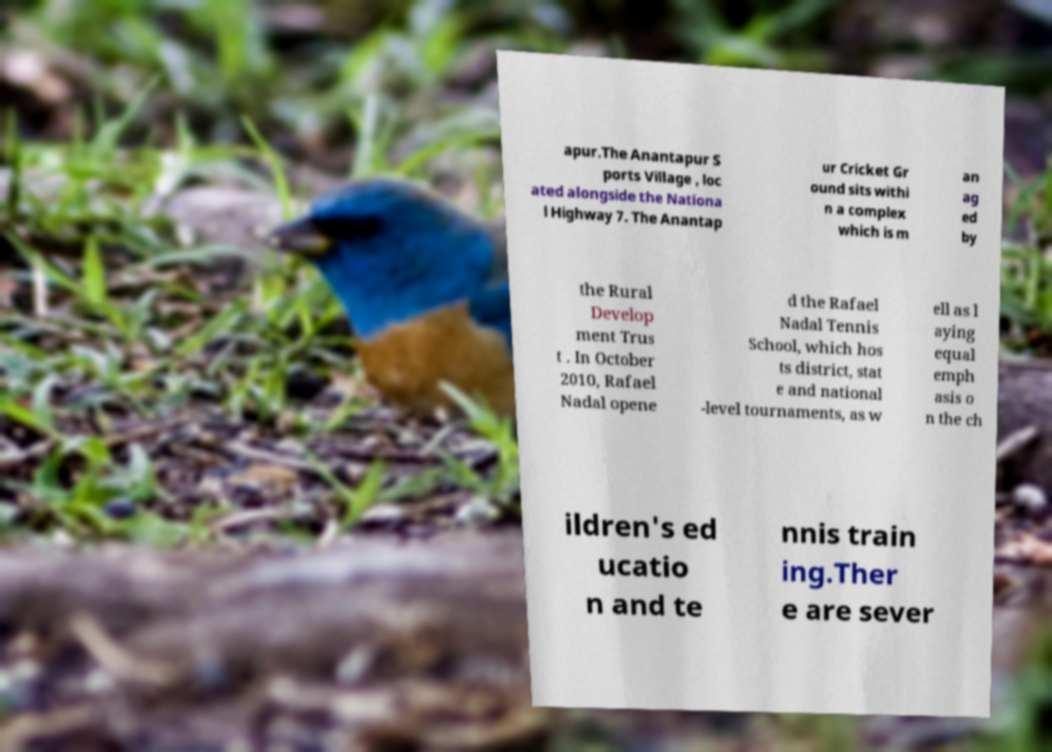What messages or text are displayed in this image? I need them in a readable, typed format. apur.The Anantapur S ports Village , loc ated alongside the Nationa l Highway 7. The Anantap ur Cricket Gr ound sits withi n a complex which is m an ag ed by the Rural Develop ment Trus t . In October 2010, Rafael Nadal opene d the Rafael Nadal Tennis School, which hos ts district, stat e and national -level tournaments, as w ell as l aying equal emph asis o n the ch ildren's ed ucatio n and te nnis train ing.Ther e are sever 